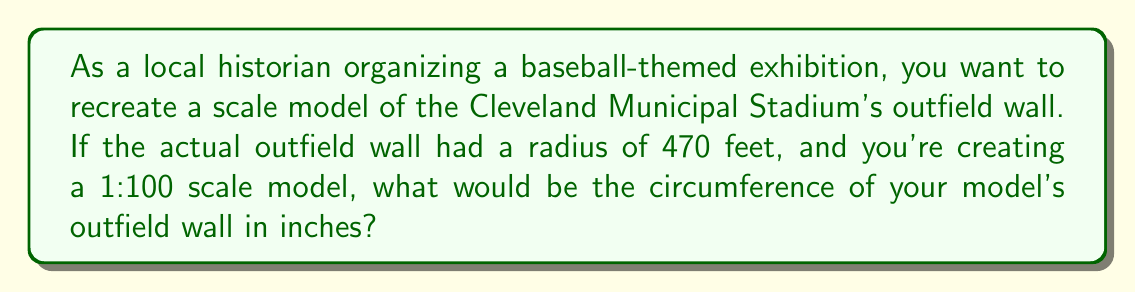Can you answer this question? To solve this problem, we'll follow these steps:

1) First, let's recall the formula for the circumference of a circle:
   $$C = 2\pi r$$
   where $C$ is the circumference and $r$ is the radius.

2) The actual radius is 470 feet, but we're making a 1:100 scale model. So we need to divide this by 100:
   $$r_{model} = \frac{470}{100} = 4.7 \text{ feet}$$

3) Now we can plug this into our circumference formula:
   $$C_{model} = 2\pi (4.7)$$

4) Let's calculate this:
   $$C_{model} = 2 \cdot 3.14159 \cdot 4.7 \approx 29.5309 \text{ feet}$$

5) The question asks for the answer in inches, so we need to convert:
   $$29.5309 \text{ feet} \cdot \frac{12 \text{ inches}}{1 \text{ foot}} = 354.3708 \text{ inches}$$

6) Rounding to the nearest inch:
   $$354.3708 \text{ inches} \approx 354 \text{ inches}$$

[asy]
unitsize(1cm);
draw(circle((0,0),4.7), blue);
label("4.7 ft", (2.35,0), E);
draw((0,0)--(4.7,0), dashed);
label("Scale model outfield", (0,-5));
[/asy]
Answer: The circumference of the scale model outfield wall would be approximately 354 inches. 